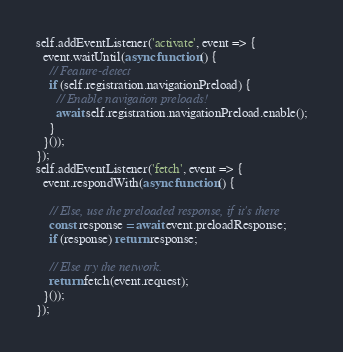<code> <loc_0><loc_0><loc_500><loc_500><_JavaScript_>self.addEventListener('activate', event => {
  event.waitUntil(async function() {
    // Feature-detect
    if (self.registration.navigationPreload) {
      // Enable navigation preloads!
      await self.registration.navigationPreload.enable();
    }
  }());
});
self.addEventListener('fetch', event => {
  event.respondWith(async function() {

    // Else, use the preloaded response, if it's there
    const response = await event.preloadResponse;
    if (response) return response;

    // Else try the network.
    return fetch(event.request);
  }());
});
</code> 